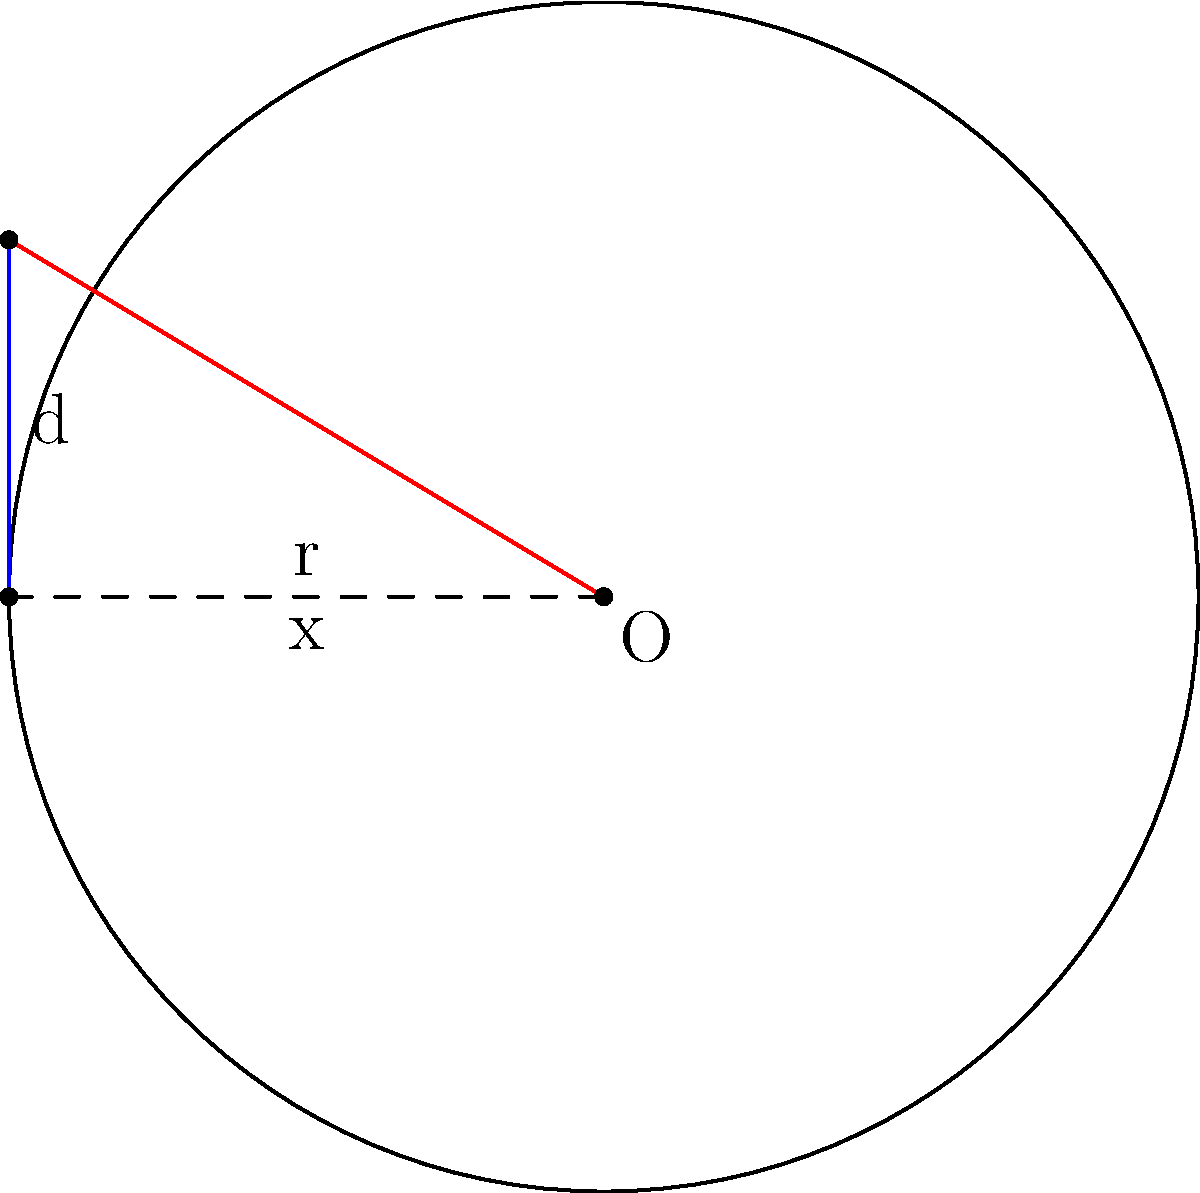In a freemium game, user retention is often visualized using a circular graph. The radius of this circle represents the total user base, while chords represent different user segments. Given a circular graph with radius $r = 5$ units and a chord with a perpendicular distance $d = 3$ units from the center, calculate the length of the chord. How might this chord length relate to a specific user segment in your game's retention strategy? Let's approach this step-by-step:

1) In a circle, we can form a right triangle using half of the chord, the radius perpendicular to the chord, and the radius to the end of the chord.

2) Let $x$ be half the length of the chord. We need to find $2x$.

3) Using the Pythagorean theorem in this right triangle:

   $$r^2 = x^2 + d^2$$

4) Substituting the known values:

   $$5^2 = x^2 + 3^2$$

5) Simplify:

   $$25 = x^2 + 9$$

6) Solve for $x^2$:

   $$x^2 = 25 - 9 = 16$$

7) Take the square root of both sides:

   $$x = 4$$

8) Remember, this is half the chord length. The full length is $2x$:

   $$\text{Chord length} = 2x = 2(4) = 8$$

In the context of user acquisition for freemium games, this chord length could represent a specific user segment, such as active daily users or users who have made in-app purchases. The ratio of this segment (chord length) to the total user base (circle circumference) could provide insights into the effectiveness of retention strategies for this particular group.
Answer: $8$ units 